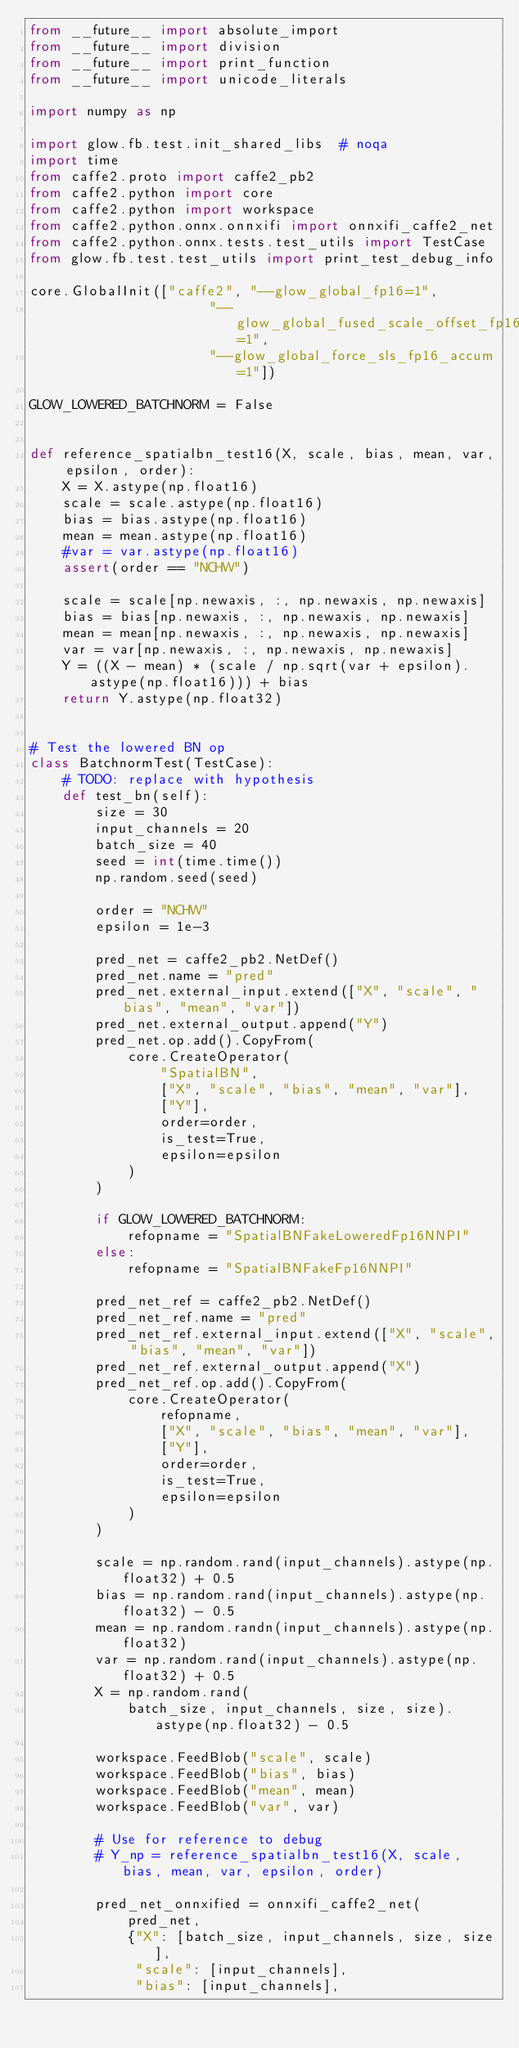Convert code to text. <code><loc_0><loc_0><loc_500><loc_500><_Python_>from __future__ import absolute_import
from __future__ import division
from __future__ import print_function
from __future__ import unicode_literals

import numpy as np

import glow.fb.test.init_shared_libs  # noqa
import time
from caffe2.proto import caffe2_pb2
from caffe2.python import core
from caffe2.python import workspace
from caffe2.python.onnx.onnxifi import onnxifi_caffe2_net
from caffe2.python.onnx.tests.test_utils import TestCase
from glow.fb.test.test_utils import print_test_debug_info

core.GlobalInit(["caffe2", "--glow_global_fp16=1",
                      "--glow_global_fused_scale_offset_fp16=1",
                      "--glow_global_force_sls_fp16_accum=1"])

GLOW_LOWERED_BATCHNORM = False


def reference_spatialbn_test16(X, scale, bias, mean, var, epsilon, order):
    X = X.astype(np.float16)
    scale = scale.astype(np.float16)
    bias = bias.astype(np.float16)
    mean = mean.astype(np.float16)
    #var = var.astype(np.float16)
    assert(order == "NCHW")

    scale = scale[np.newaxis, :, np.newaxis, np.newaxis]
    bias = bias[np.newaxis, :, np.newaxis, np.newaxis]
    mean = mean[np.newaxis, :, np.newaxis, np.newaxis]
    var = var[np.newaxis, :, np.newaxis, np.newaxis]
    Y = ((X - mean) * (scale / np.sqrt(var + epsilon).astype(np.float16))) + bias
    return Y.astype(np.float32)


# Test the lowered BN op
class BatchnormTest(TestCase):
    # TODO: replace with hypothesis
    def test_bn(self):
        size = 30
        input_channels = 20
        batch_size = 40
        seed = int(time.time())
        np.random.seed(seed)

        order = "NCHW"
        epsilon = 1e-3

        pred_net = caffe2_pb2.NetDef()
        pred_net.name = "pred"
        pred_net.external_input.extend(["X", "scale", "bias", "mean", "var"])
        pred_net.external_output.append("Y")
        pred_net.op.add().CopyFrom(
            core.CreateOperator(
                "SpatialBN",
                ["X", "scale", "bias", "mean", "var"],
                ["Y"],
                order=order,
                is_test=True,
                epsilon=epsilon
            )
        )

        if GLOW_LOWERED_BATCHNORM:
            refopname = "SpatialBNFakeLoweredFp16NNPI"
        else:
            refopname = "SpatialBNFakeFp16NNPI"

        pred_net_ref = caffe2_pb2.NetDef()
        pred_net_ref.name = "pred"
        pred_net_ref.external_input.extend(["X", "scale", "bias", "mean", "var"])
        pred_net_ref.external_output.append("X")
        pred_net_ref.op.add().CopyFrom(
            core.CreateOperator(
                refopname,
                ["X", "scale", "bias", "mean", "var"],
                ["Y"],
                order=order,
                is_test=True,
                epsilon=epsilon
            )
        )

        scale = np.random.rand(input_channels).astype(np.float32) + 0.5
        bias = np.random.rand(input_channels).astype(np.float32) - 0.5
        mean = np.random.randn(input_channels).astype(np.float32)
        var = np.random.rand(input_channels).astype(np.float32) + 0.5
        X = np.random.rand(
            batch_size, input_channels, size, size).astype(np.float32) - 0.5

        workspace.FeedBlob("scale", scale)
        workspace.FeedBlob("bias", bias)
        workspace.FeedBlob("mean", mean)
        workspace.FeedBlob("var", var)

        # Use for reference to debug
        # Y_np = reference_spatialbn_test16(X, scale, bias, mean, var, epsilon, order)

        pred_net_onnxified = onnxifi_caffe2_net(
            pred_net,
            {"X": [batch_size, input_channels, size, size],
             "scale": [input_channels],
             "bias": [input_channels],</code> 